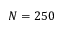Convert formula to latex. <formula><loc_0><loc_0><loc_500><loc_500>N = 2 5 0</formula> 